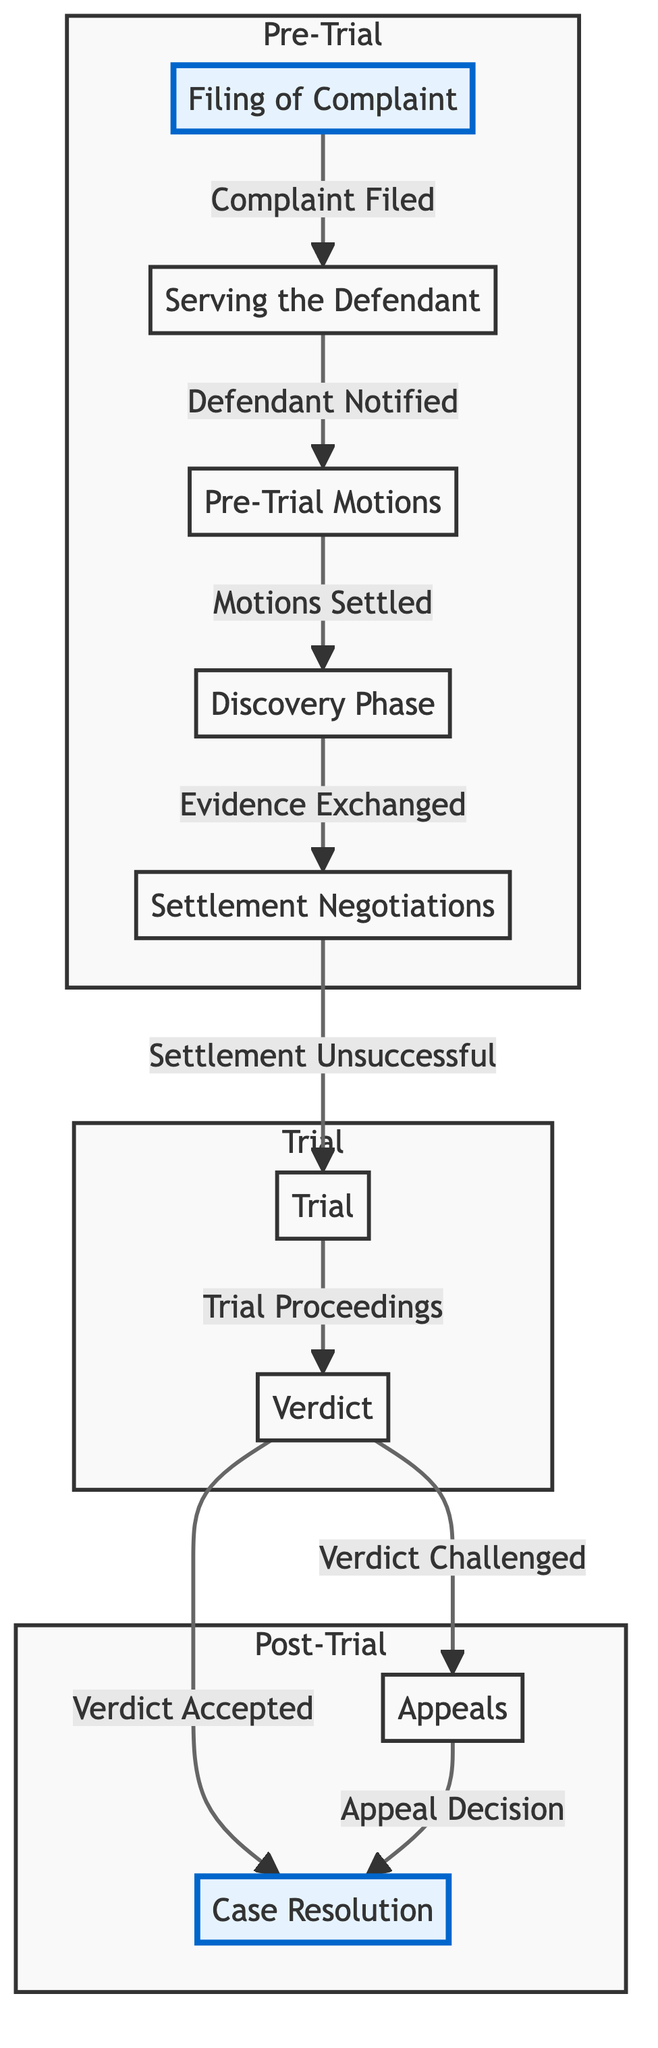What is the first stage in the legal case lifecycle? The diagram begins with the node labeled "Filing of Complaint," indicating that this is the first stage in the legal case lifecycle.
Answer: Filing of Complaint How many stages are there in total in the diagram? The diagram consists of eight distinct stages, which can be counted from the nodes present in the flowchart, including filing, trial, and resolution phases.
Answer: Eight What stage follows "Discovery Phase"? According to the flow of the diagram, "Discovery Phase" is followed by "Settlement Negotiations," indicating that the process moves from one to the next in sequence.
Answer: Settlement Negotiations If the "Verdict" is accepted, what is the next step according to the diagram? The diagram shows that if the "Verdict" is accepted, it goes directly to "Case Resolution," which indicates the conclusion of the process.
Answer: Case Resolution What is the relationship between "Trial" and "Verdict"? The flowchart indicates that "Trial" leads to "Verdict," meaning that the verdict is a direct result of the trial proceedings, establishing a sequential relationship between these stages.
Answer: Trial leads to Verdict What happens if "Settlement Negotiations" are unsuccessful? The diagram indicates that if "Settlement Negotiations" are unsuccessful, the process progresses to the "Trial" stage, demonstrating the pathway through the legal case lifecycle in case of a failed settlement.
Answer: Trial What does the subgraph "Post-Trial" include? The "Post-Trial" subgraph comprises the stages "Appeals" and "Case Resolution," which are directly positioned under the Post-Trial section in the flowchart.
Answer: Appeals and Case Resolution What stage is categorized as "Pre-Trial"? The stages included in the "Pre-Trial" subgraph are "Filing of Complaint," "Serving the Defendant," "Pre-Trial Motions," "Discovery Phase," and "Settlement Negotiations," indicating the full range of activities before a trial.
Answer: Filing of Complaint, Serving the Defendant, Pre-Trial Motions, Discovery Phase, Settlement Negotiations If a verdict is challenged, what stage does it lead to? According to the diagram, if a "Verdict" is challenged, it leads to the "Appeals" stage, showing the process for contesting the outcome of a trial.
Answer: Appeals 